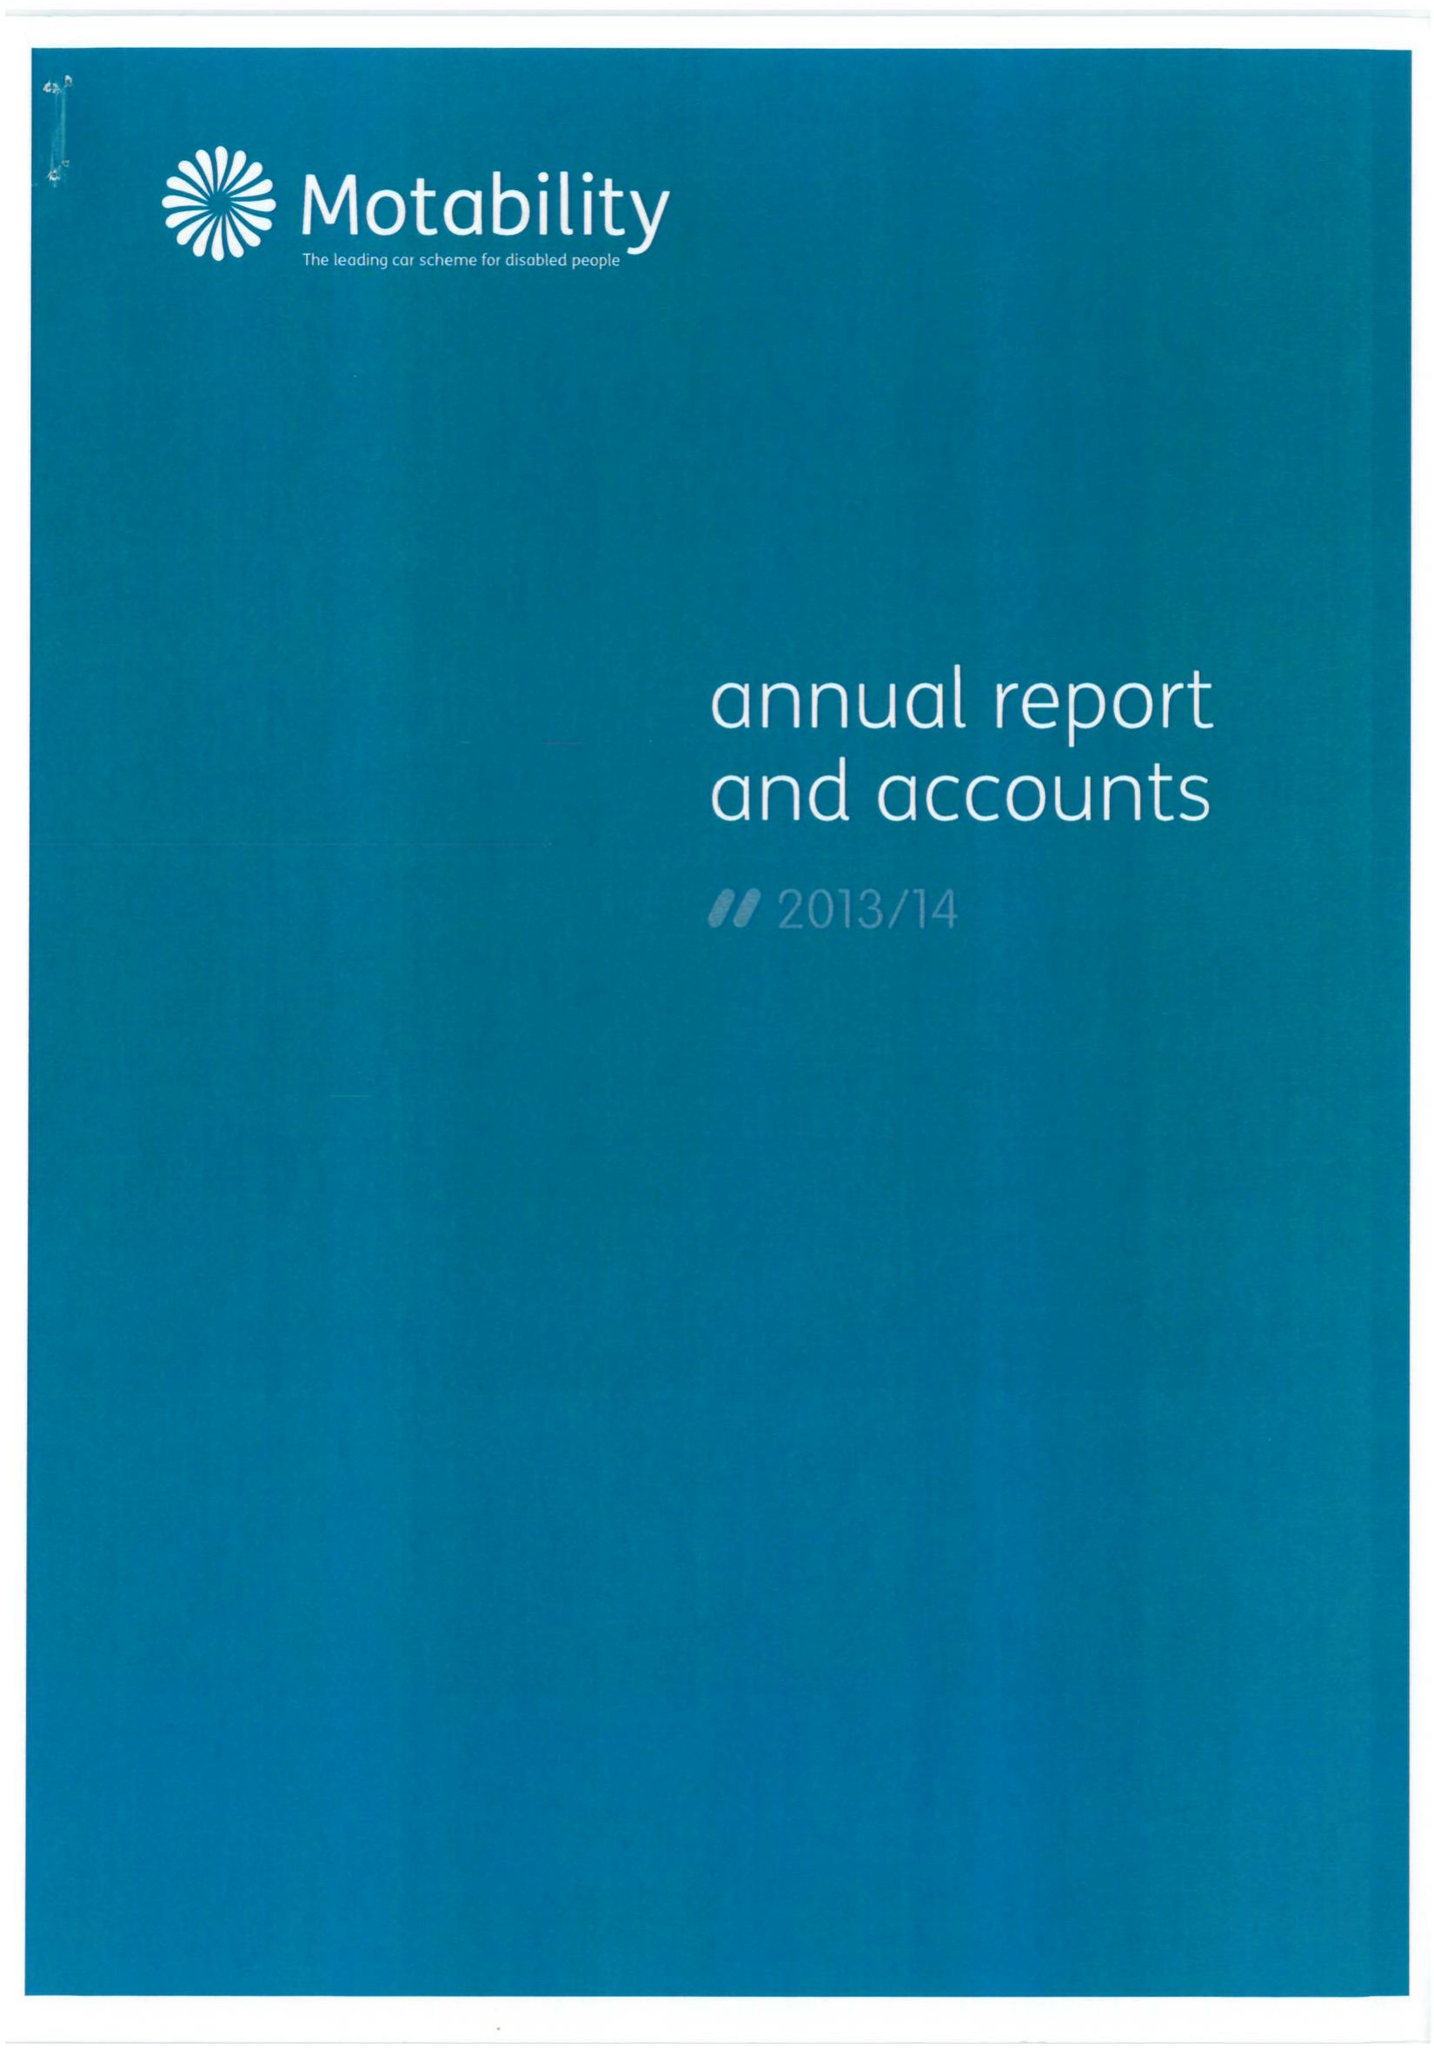What is the value for the charity_number?
Answer the question using a single word or phrase. 299745 